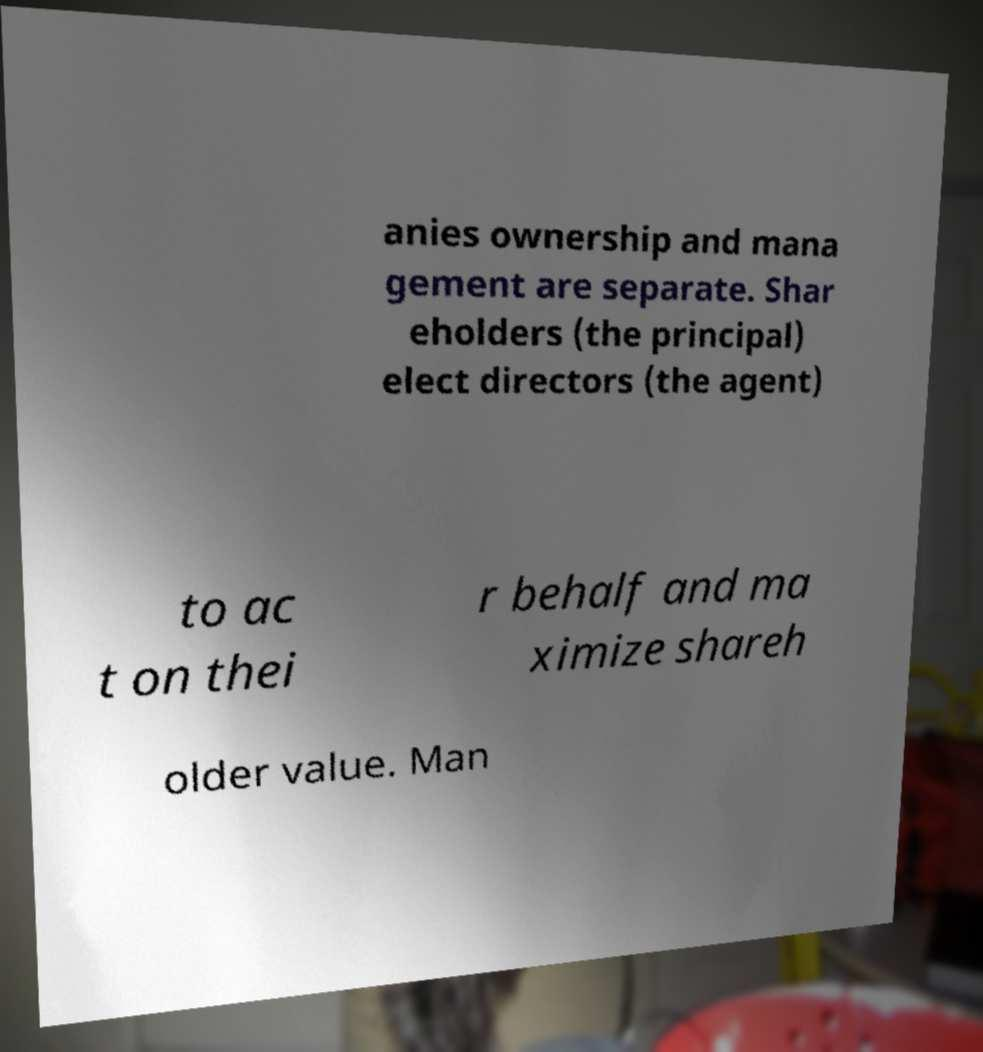Could you extract and type out the text from this image? anies ownership and mana gement are separate. Shar eholders (the principal) elect directors (the agent) to ac t on thei r behalf and ma ximize shareh older value. Man 